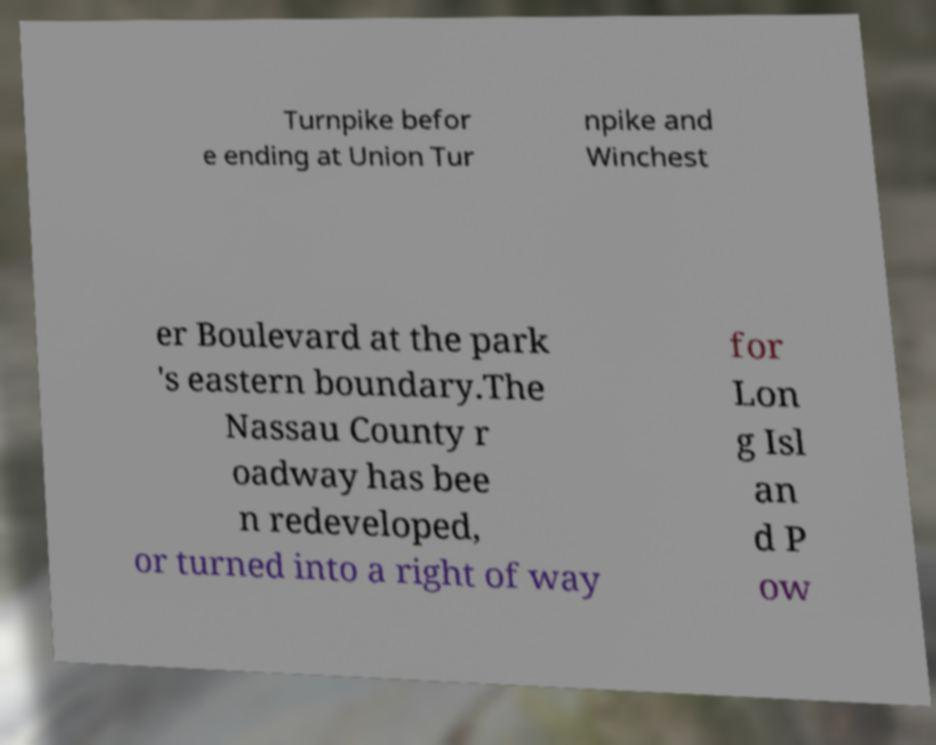Could you extract and type out the text from this image? Turnpike befor e ending at Union Tur npike and Winchest er Boulevard at the park 's eastern boundary.The Nassau County r oadway has bee n redeveloped, or turned into a right of way for Lon g Isl an d P ow 